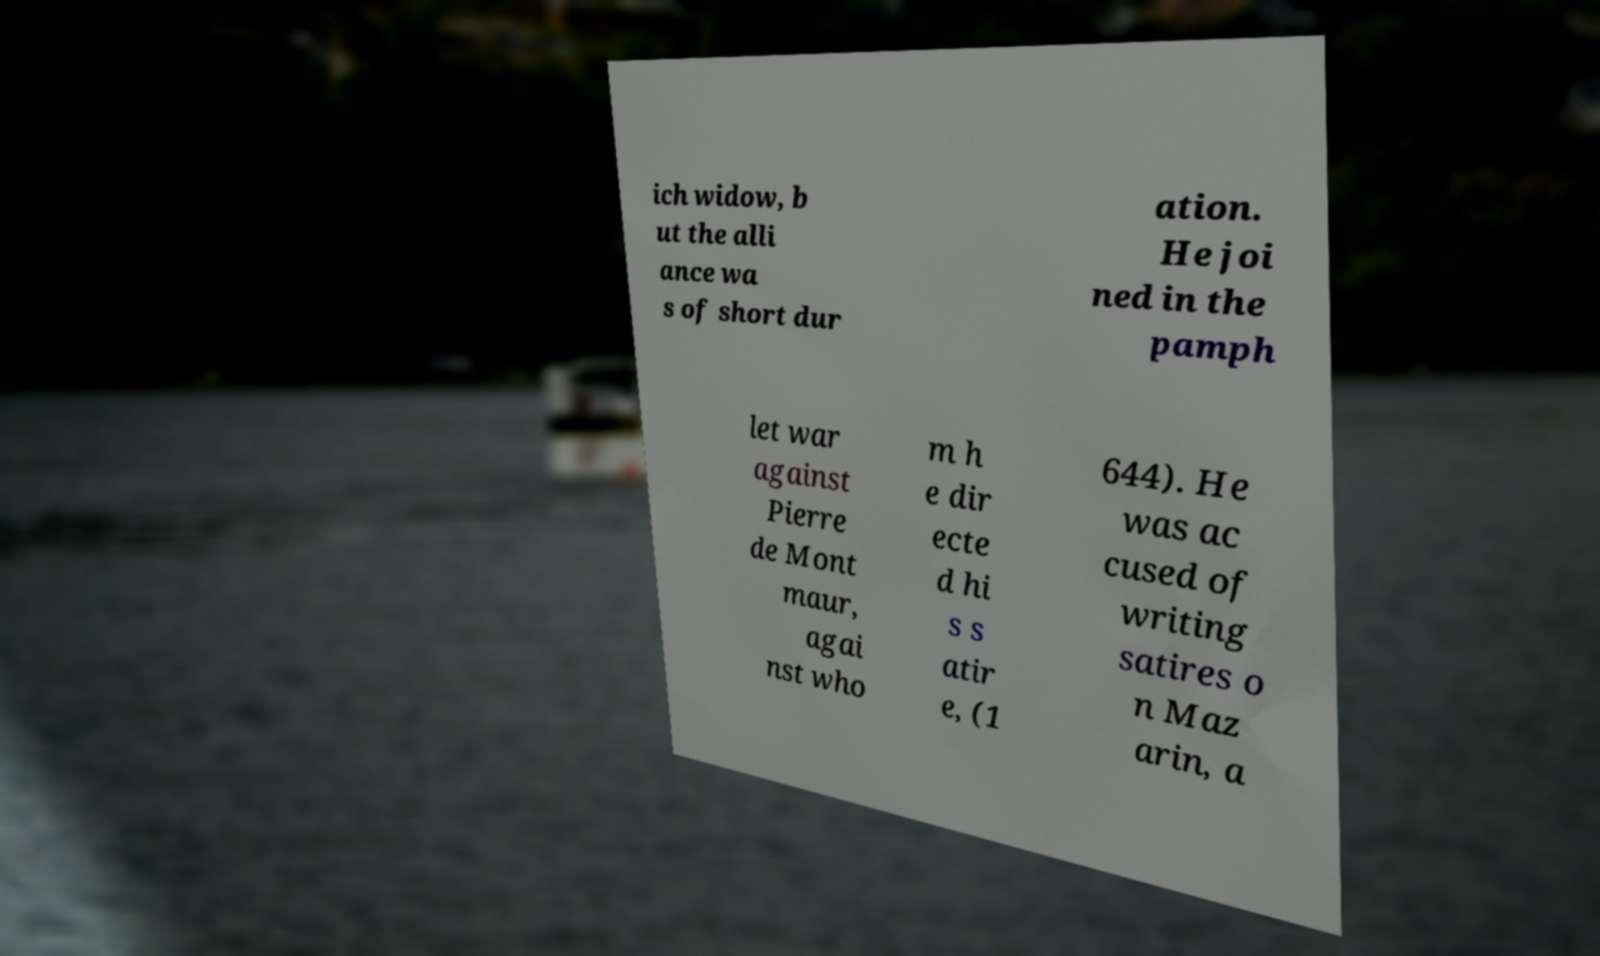Could you extract and type out the text from this image? ich widow, b ut the alli ance wa s of short dur ation. He joi ned in the pamph let war against Pierre de Mont maur, agai nst who m h e dir ecte d hi s s atir e, (1 644). He was ac cused of writing satires o n Maz arin, a 